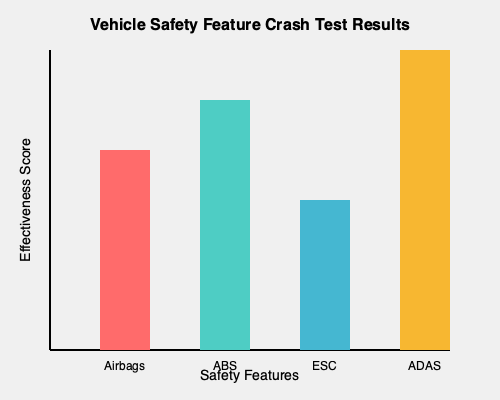Based on the crash test results shown in the graph, which safety feature appears to be the most overrated, likely prompting car manufacturers to slap it on every vehicle like a band-aid on a bullet wound? To answer this question, we need to analyze the effectiveness scores of each safety feature presented in the graph:

1. Airbags: The red bar represents airbags, with an effectiveness score of about 60%.
2. ABS (Anti-lock Braking System): The teal bar represents ABS, with an effectiveness score of about 75%.
3. ESC (Electronic Stability Control): The blue bar represents ESC, with an effectiveness score of about 45%.
4. ADAS (Advanced Driver Assistance Systems): The yellow bar represents ADAS, with the highest effectiveness score of about 90%.

The question asks for the most overrated feature, which would be the one with the lowest effectiveness score despite being commonly included in vehicles. In this case, ESC has the lowest effectiveness score at approximately 45%.

Given the sarcastic tone of the persona, the answer should reflect a critical view of the feature with the lowest effectiveness, suggesting that it's widely used despite its relatively low impact on safety.
Answer: Electronic Stability Control (ESC) 